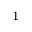<formula> <loc_0><loc_0><loc_500><loc_500>^ { 1 }</formula> 